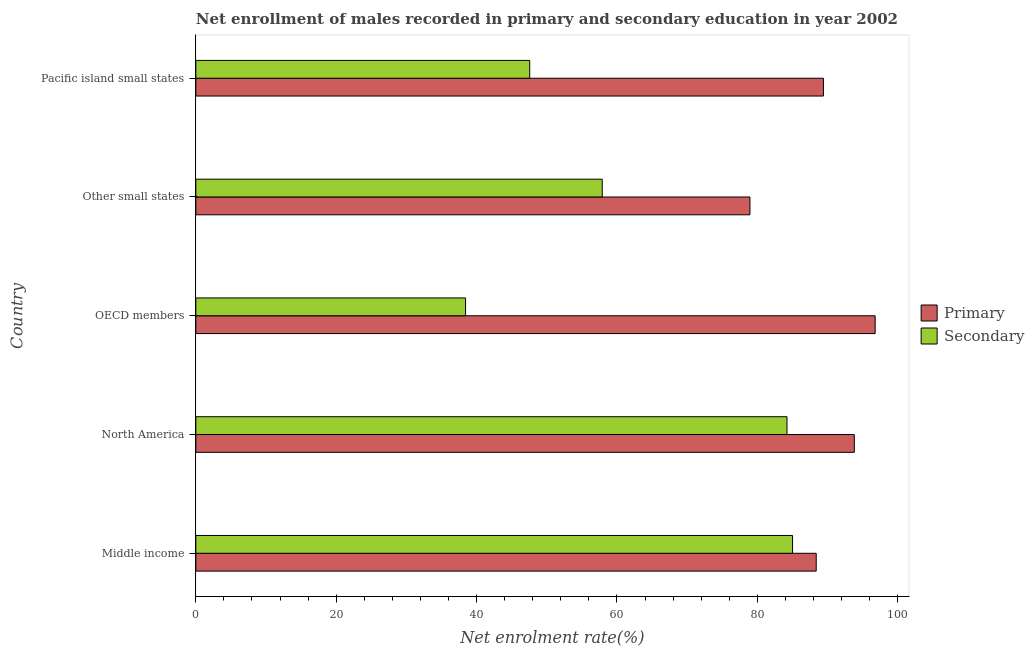How many groups of bars are there?
Your answer should be very brief. 5. What is the label of the 2nd group of bars from the top?
Your answer should be very brief. Other small states. What is the enrollment rate in primary education in North America?
Provide a short and direct response. 93.82. Across all countries, what is the maximum enrollment rate in primary education?
Your response must be concise. 96.79. Across all countries, what is the minimum enrollment rate in primary education?
Ensure brevity in your answer.  78.95. In which country was the enrollment rate in primary education maximum?
Provide a succinct answer. OECD members. In which country was the enrollment rate in secondary education minimum?
Offer a terse response. OECD members. What is the total enrollment rate in primary education in the graph?
Ensure brevity in your answer.  447.36. What is the difference between the enrollment rate in secondary education in North America and that in Pacific island small states?
Make the answer very short. 36.66. What is the difference between the enrollment rate in secondary education in Middle income and the enrollment rate in primary education in OECD members?
Offer a very short reply. -11.77. What is the average enrollment rate in secondary education per country?
Offer a terse response. 62.63. What is the difference between the enrollment rate in secondary education and enrollment rate in primary education in Middle income?
Give a very brief answer. -3.37. In how many countries, is the enrollment rate in primary education greater than 48 %?
Ensure brevity in your answer.  5. What is the ratio of the enrollment rate in primary education in OECD members to that in Other small states?
Provide a succinct answer. 1.23. What is the difference between the highest and the second highest enrollment rate in secondary education?
Provide a succinct answer. 0.79. What is the difference between the highest and the lowest enrollment rate in secondary education?
Your answer should be very brief. 46.59. What does the 1st bar from the top in Pacific island small states represents?
Give a very brief answer. Secondary. What does the 1st bar from the bottom in Other small states represents?
Ensure brevity in your answer.  Primary. How many bars are there?
Keep it short and to the point. 10. How many countries are there in the graph?
Ensure brevity in your answer.  5. Does the graph contain any zero values?
Keep it short and to the point. No. Does the graph contain grids?
Make the answer very short. No. Where does the legend appear in the graph?
Your response must be concise. Center right. How many legend labels are there?
Provide a short and direct response. 2. How are the legend labels stacked?
Your answer should be compact. Vertical. What is the title of the graph?
Your response must be concise. Net enrollment of males recorded in primary and secondary education in year 2002. What is the label or title of the X-axis?
Provide a short and direct response. Net enrolment rate(%). What is the label or title of the Y-axis?
Offer a very short reply. Country. What is the Net enrolment rate(%) in Primary in Middle income?
Keep it short and to the point. 88.39. What is the Net enrolment rate(%) of Secondary in Middle income?
Provide a short and direct response. 85.02. What is the Net enrolment rate(%) of Primary in North America?
Provide a succinct answer. 93.82. What is the Net enrolment rate(%) of Secondary in North America?
Make the answer very short. 84.23. What is the Net enrolment rate(%) in Primary in OECD members?
Provide a succinct answer. 96.79. What is the Net enrolment rate(%) in Secondary in OECD members?
Offer a very short reply. 38.43. What is the Net enrolment rate(%) of Primary in Other small states?
Your answer should be compact. 78.95. What is the Net enrolment rate(%) in Secondary in Other small states?
Ensure brevity in your answer.  57.9. What is the Net enrolment rate(%) of Primary in Pacific island small states?
Offer a very short reply. 89.41. What is the Net enrolment rate(%) of Secondary in Pacific island small states?
Offer a terse response. 47.57. Across all countries, what is the maximum Net enrolment rate(%) in Primary?
Make the answer very short. 96.79. Across all countries, what is the maximum Net enrolment rate(%) in Secondary?
Provide a short and direct response. 85.02. Across all countries, what is the minimum Net enrolment rate(%) of Primary?
Make the answer very short. 78.95. Across all countries, what is the minimum Net enrolment rate(%) of Secondary?
Your answer should be compact. 38.43. What is the total Net enrolment rate(%) of Primary in the graph?
Provide a short and direct response. 447.36. What is the total Net enrolment rate(%) of Secondary in the graph?
Provide a short and direct response. 313.15. What is the difference between the Net enrolment rate(%) in Primary in Middle income and that in North America?
Keep it short and to the point. -5.43. What is the difference between the Net enrolment rate(%) in Secondary in Middle income and that in North America?
Your answer should be compact. 0.79. What is the difference between the Net enrolment rate(%) of Primary in Middle income and that in OECD members?
Give a very brief answer. -8.4. What is the difference between the Net enrolment rate(%) of Secondary in Middle income and that in OECD members?
Keep it short and to the point. 46.59. What is the difference between the Net enrolment rate(%) of Primary in Middle income and that in Other small states?
Offer a terse response. 9.44. What is the difference between the Net enrolment rate(%) in Secondary in Middle income and that in Other small states?
Your answer should be compact. 27.12. What is the difference between the Net enrolment rate(%) of Primary in Middle income and that in Pacific island small states?
Provide a short and direct response. -1.03. What is the difference between the Net enrolment rate(%) of Secondary in Middle income and that in Pacific island small states?
Your response must be concise. 37.45. What is the difference between the Net enrolment rate(%) in Primary in North America and that in OECD members?
Your answer should be very brief. -2.97. What is the difference between the Net enrolment rate(%) of Secondary in North America and that in OECD members?
Offer a terse response. 45.8. What is the difference between the Net enrolment rate(%) in Primary in North America and that in Other small states?
Make the answer very short. 14.87. What is the difference between the Net enrolment rate(%) in Secondary in North America and that in Other small states?
Give a very brief answer. 26.33. What is the difference between the Net enrolment rate(%) of Primary in North America and that in Pacific island small states?
Your answer should be very brief. 4.4. What is the difference between the Net enrolment rate(%) of Secondary in North America and that in Pacific island small states?
Offer a very short reply. 36.66. What is the difference between the Net enrolment rate(%) of Primary in OECD members and that in Other small states?
Ensure brevity in your answer.  17.84. What is the difference between the Net enrolment rate(%) of Secondary in OECD members and that in Other small states?
Give a very brief answer. -19.47. What is the difference between the Net enrolment rate(%) in Primary in OECD members and that in Pacific island small states?
Offer a very short reply. 7.37. What is the difference between the Net enrolment rate(%) in Secondary in OECD members and that in Pacific island small states?
Your answer should be very brief. -9.14. What is the difference between the Net enrolment rate(%) of Primary in Other small states and that in Pacific island small states?
Give a very brief answer. -10.47. What is the difference between the Net enrolment rate(%) of Secondary in Other small states and that in Pacific island small states?
Your answer should be very brief. 10.33. What is the difference between the Net enrolment rate(%) in Primary in Middle income and the Net enrolment rate(%) in Secondary in North America?
Provide a succinct answer. 4.16. What is the difference between the Net enrolment rate(%) of Primary in Middle income and the Net enrolment rate(%) of Secondary in OECD members?
Offer a terse response. 49.96. What is the difference between the Net enrolment rate(%) of Primary in Middle income and the Net enrolment rate(%) of Secondary in Other small states?
Your answer should be very brief. 30.49. What is the difference between the Net enrolment rate(%) in Primary in Middle income and the Net enrolment rate(%) in Secondary in Pacific island small states?
Provide a succinct answer. 40.82. What is the difference between the Net enrolment rate(%) in Primary in North America and the Net enrolment rate(%) in Secondary in OECD members?
Keep it short and to the point. 55.39. What is the difference between the Net enrolment rate(%) of Primary in North America and the Net enrolment rate(%) of Secondary in Other small states?
Your response must be concise. 35.92. What is the difference between the Net enrolment rate(%) in Primary in North America and the Net enrolment rate(%) in Secondary in Pacific island small states?
Your answer should be very brief. 46.25. What is the difference between the Net enrolment rate(%) in Primary in OECD members and the Net enrolment rate(%) in Secondary in Other small states?
Your answer should be compact. 38.89. What is the difference between the Net enrolment rate(%) in Primary in OECD members and the Net enrolment rate(%) in Secondary in Pacific island small states?
Offer a very short reply. 49.22. What is the difference between the Net enrolment rate(%) of Primary in Other small states and the Net enrolment rate(%) of Secondary in Pacific island small states?
Keep it short and to the point. 31.38. What is the average Net enrolment rate(%) in Primary per country?
Provide a succinct answer. 89.47. What is the average Net enrolment rate(%) in Secondary per country?
Offer a very short reply. 62.63. What is the difference between the Net enrolment rate(%) of Primary and Net enrolment rate(%) of Secondary in Middle income?
Give a very brief answer. 3.37. What is the difference between the Net enrolment rate(%) in Primary and Net enrolment rate(%) in Secondary in North America?
Make the answer very short. 9.59. What is the difference between the Net enrolment rate(%) of Primary and Net enrolment rate(%) of Secondary in OECD members?
Make the answer very short. 58.36. What is the difference between the Net enrolment rate(%) in Primary and Net enrolment rate(%) in Secondary in Other small states?
Offer a very short reply. 21.05. What is the difference between the Net enrolment rate(%) in Primary and Net enrolment rate(%) in Secondary in Pacific island small states?
Offer a terse response. 41.84. What is the ratio of the Net enrolment rate(%) in Primary in Middle income to that in North America?
Ensure brevity in your answer.  0.94. What is the ratio of the Net enrolment rate(%) in Secondary in Middle income to that in North America?
Make the answer very short. 1.01. What is the ratio of the Net enrolment rate(%) of Primary in Middle income to that in OECD members?
Provide a succinct answer. 0.91. What is the ratio of the Net enrolment rate(%) in Secondary in Middle income to that in OECD members?
Give a very brief answer. 2.21. What is the ratio of the Net enrolment rate(%) of Primary in Middle income to that in Other small states?
Make the answer very short. 1.12. What is the ratio of the Net enrolment rate(%) in Secondary in Middle income to that in Other small states?
Provide a succinct answer. 1.47. What is the ratio of the Net enrolment rate(%) in Primary in Middle income to that in Pacific island small states?
Give a very brief answer. 0.99. What is the ratio of the Net enrolment rate(%) of Secondary in Middle income to that in Pacific island small states?
Offer a terse response. 1.79. What is the ratio of the Net enrolment rate(%) in Primary in North America to that in OECD members?
Make the answer very short. 0.97. What is the ratio of the Net enrolment rate(%) of Secondary in North America to that in OECD members?
Provide a succinct answer. 2.19. What is the ratio of the Net enrolment rate(%) in Primary in North America to that in Other small states?
Offer a terse response. 1.19. What is the ratio of the Net enrolment rate(%) of Secondary in North America to that in Other small states?
Ensure brevity in your answer.  1.45. What is the ratio of the Net enrolment rate(%) in Primary in North America to that in Pacific island small states?
Ensure brevity in your answer.  1.05. What is the ratio of the Net enrolment rate(%) of Secondary in North America to that in Pacific island small states?
Make the answer very short. 1.77. What is the ratio of the Net enrolment rate(%) in Primary in OECD members to that in Other small states?
Provide a short and direct response. 1.23. What is the ratio of the Net enrolment rate(%) of Secondary in OECD members to that in Other small states?
Make the answer very short. 0.66. What is the ratio of the Net enrolment rate(%) of Primary in OECD members to that in Pacific island small states?
Provide a succinct answer. 1.08. What is the ratio of the Net enrolment rate(%) in Secondary in OECD members to that in Pacific island small states?
Your response must be concise. 0.81. What is the ratio of the Net enrolment rate(%) in Primary in Other small states to that in Pacific island small states?
Offer a very short reply. 0.88. What is the ratio of the Net enrolment rate(%) in Secondary in Other small states to that in Pacific island small states?
Make the answer very short. 1.22. What is the difference between the highest and the second highest Net enrolment rate(%) of Primary?
Your response must be concise. 2.97. What is the difference between the highest and the second highest Net enrolment rate(%) in Secondary?
Offer a very short reply. 0.79. What is the difference between the highest and the lowest Net enrolment rate(%) of Primary?
Provide a short and direct response. 17.84. What is the difference between the highest and the lowest Net enrolment rate(%) in Secondary?
Your answer should be compact. 46.59. 